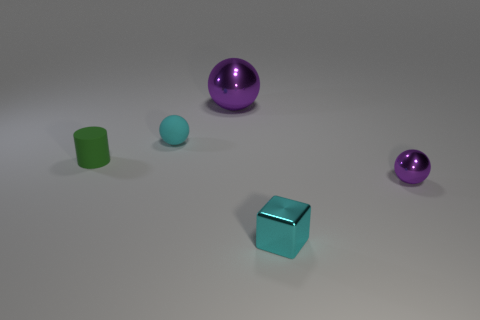There is a object that is the same color as the small matte sphere; what is its shape?
Your answer should be compact. Cube. What number of other things are there of the same size as the green matte thing?
Give a very brief answer. 3. Is there anything else that is the same shape as the tiny green thing?
Your response must be concise. No. Is the number of tiny purple metal spheres in front of the large object the same as the number of small cyan rubber spheres?
Keep it short and to the point. Yes. How many cubes are the same material as the large ball?
Keep it short and to the point. 1. The object that is the same material as the cylinder is what color?
Your answer should be compact. Cyan. Is the large purple metal thing the same shape as the cyan shiny thing?
Your response must be concise. No. Are there any cylinders on the right side of the shiny thing behind the purple ball that is on the right side of the cyan metal cube?
Provide a short and direct response. No. How many large metal balls are the same color as the large metallic thing?
Provide a succinct answer. 0. What shape is the cyan metal thing that is the same size as the green thing?
Offer a very short reply. Cube. 